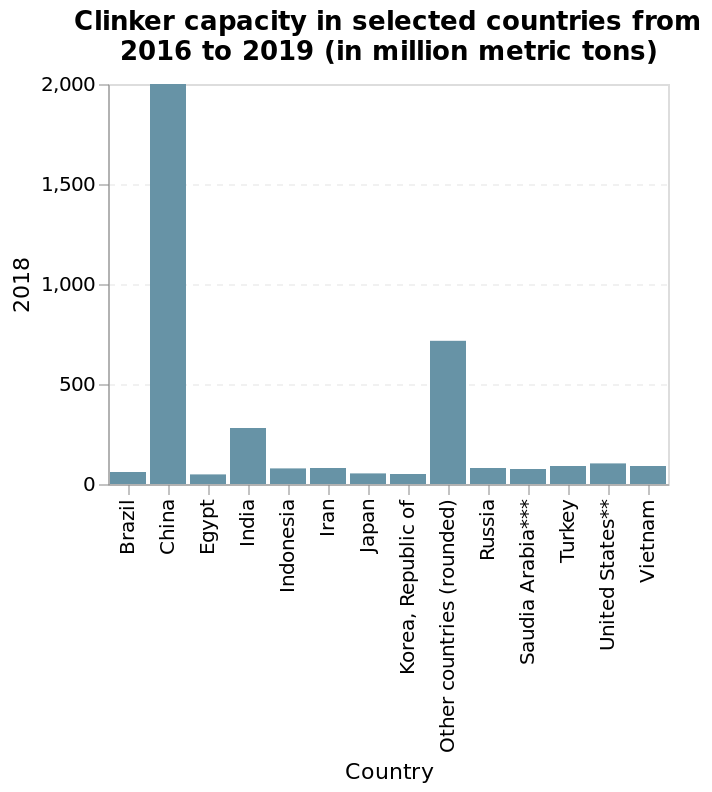<image>
What does the bar graph title indicate?  The bar graph title indicates clinker capacity in selected countries between 2016 and 2019. Does the bar graph title indicate clinker capacity in all countries between 2016 and 2019? No. The bar graph title indicates clinker capacity in selected countries between 2016 and 2019. 